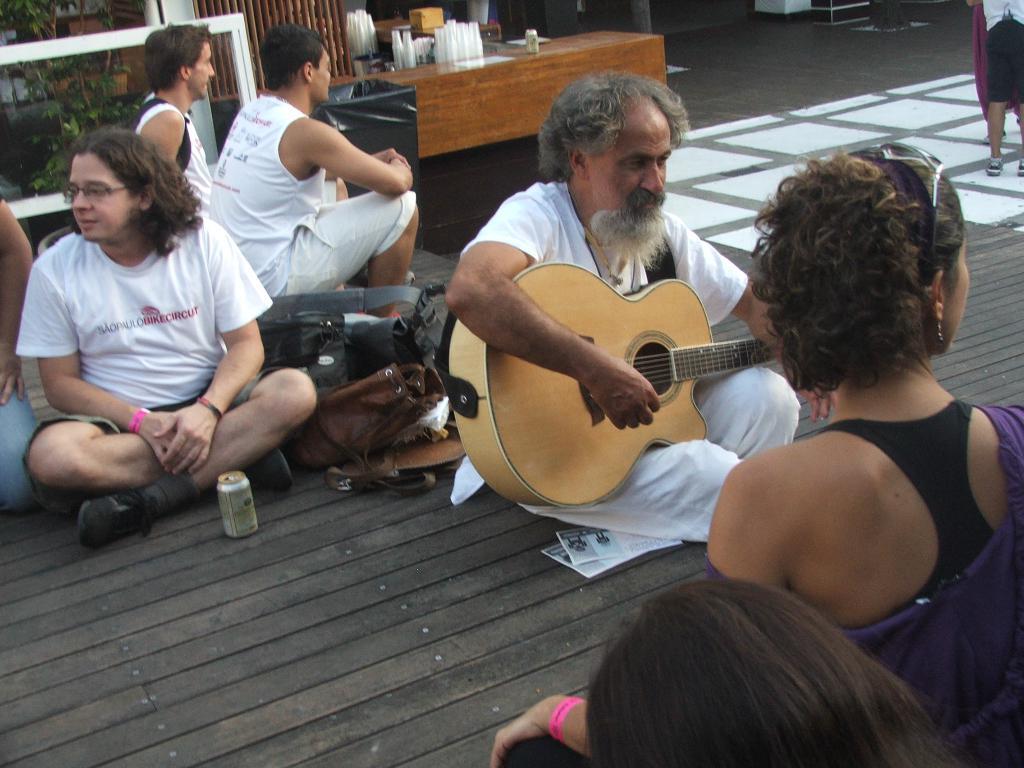Can you describe this image briefly? In this picture there are few people sitting. The man to the right is playing guitar. Beside him there is a table and on it there are glasses on it. There are plants in the image. 